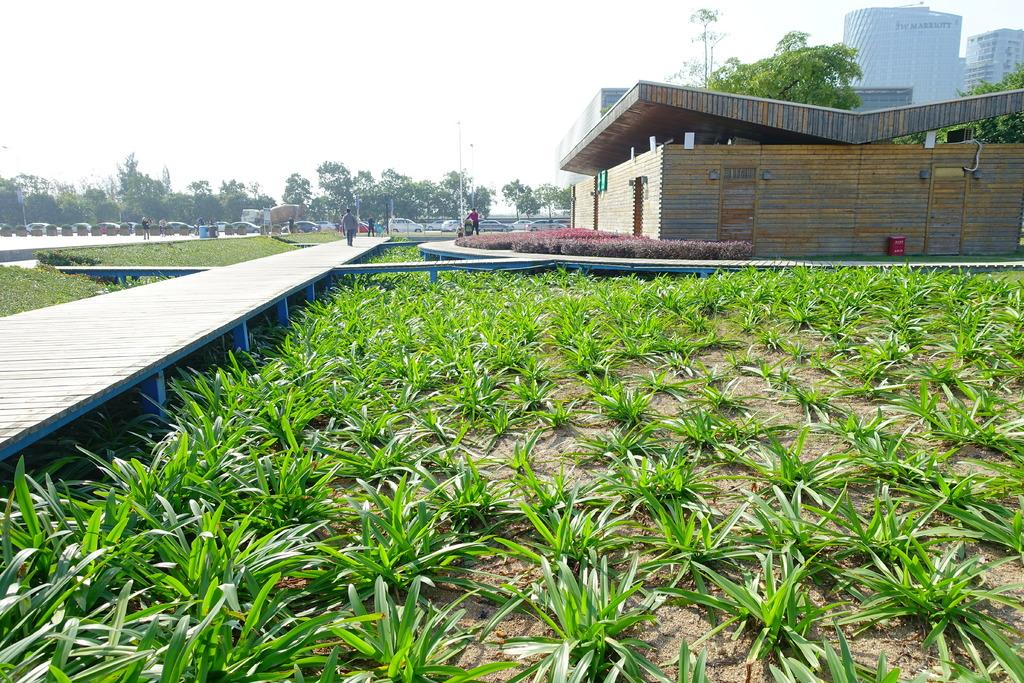What type of structures can be seen in the image? There are buildings in the image. What natural elements are present in the image? There are trees and grass in the image. What man-made objects can be seen in the image? There are poles and a wooden path in the image. What mode of transportation is visible in the image? There are vehicles in the image. Are there any living beings in the image? Yes, there are people in the image. What part of the environment is visible in the image? The sky is visible in the image. What type of soap is being used to clean the wilderness in the image? There is no soap or wilderness present in the image. What shape is the wooden path in the image? The shape of the wooden path cannot be determined from the image alone, as it is not described in the provided facts. 